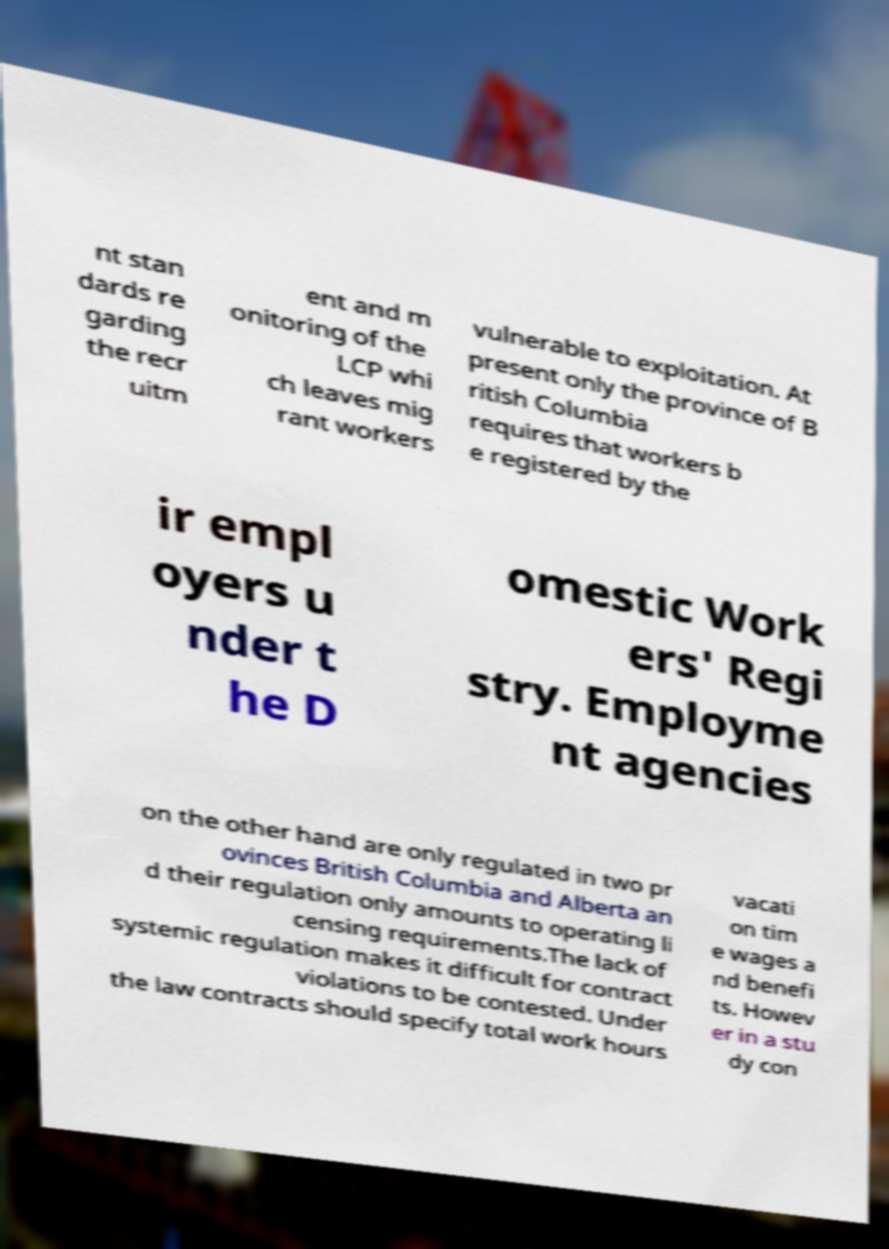There's text embedded in this image that I need extracted. Can you transcribe it verbatim? nt stan dards re garding the recr uitm ent and m onitoring of the LCP whi ch leaves mig rant workers vulnerable to exploitation. At present only the province of B ritish Columbia requires that workers b e registered by the ir empl oyers u nder t he D omestic Work ers' Regi stry. Employme nt agencies on the other hand are only regulated in two pr ovinces British Columbia and Alberta an d their regulation only amounts to operating li censing requirements.The lack of systemic regulation makes it difficult for contract violations to be contested. Under the law contracts should specify total work hours vacati on tim e wages a nd benefi ts. Howev er in a stu dy con 